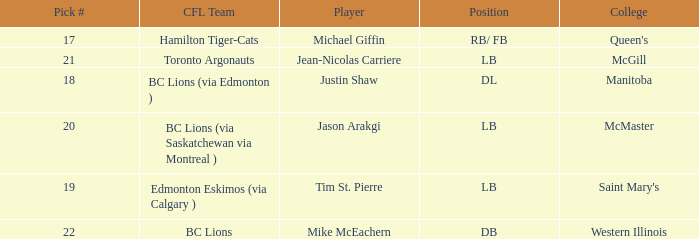What college does Jean-Nicolas Carriere play for? McGill. 